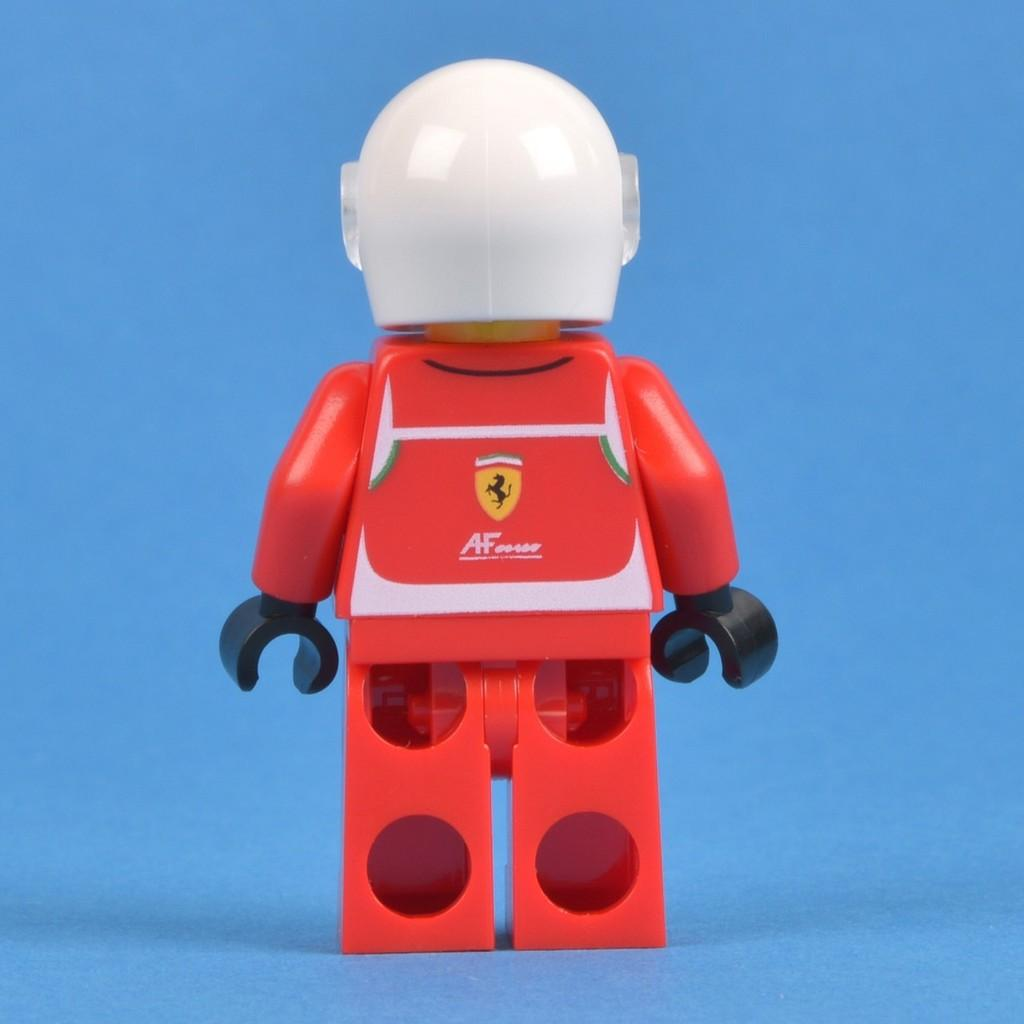What object can be seen in the image? There is a toy in the image. What color is the background of the image? The background of the image is blue. Where is the hydrant located in the image? There is no hydrant present in the image. What type of picture is hanging on the wall in the image? There is no wall or picture present in the image. 